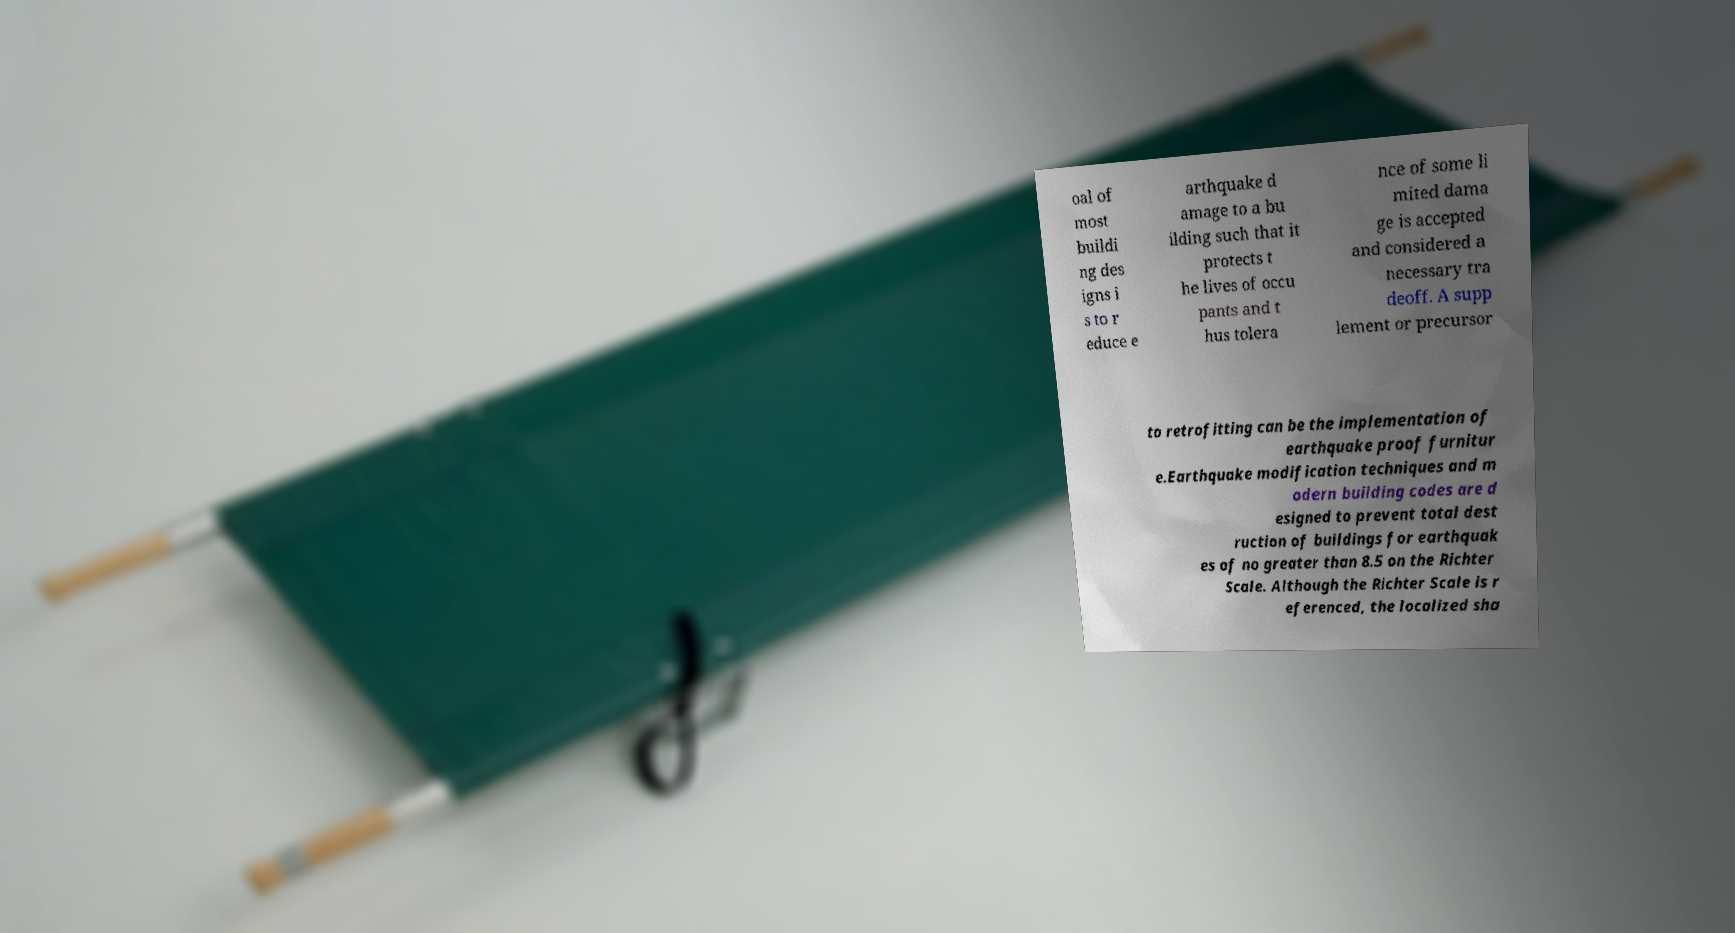There's text embedded in this image that I need extracted. Can you transcribe it verbatim? oal of most buildi ng des igns i s to r educe e arthquake d amage to a bu ilding such that it protects t he lives of occu pants and t hus tolera nce of some li mited dama ge is accepted and considered a necessary tra deoff. A supp lement or precursor to retrofitting can be the implementation of earthquake proof furnitur e.Earthquake modification techniques and m odern building codes are d esigned to prevent total dest ruction of buildings for earthquak es of no greater than 8.5 on the Richter Scale. Although the Richter Scale is r eferenced, the localized sha 